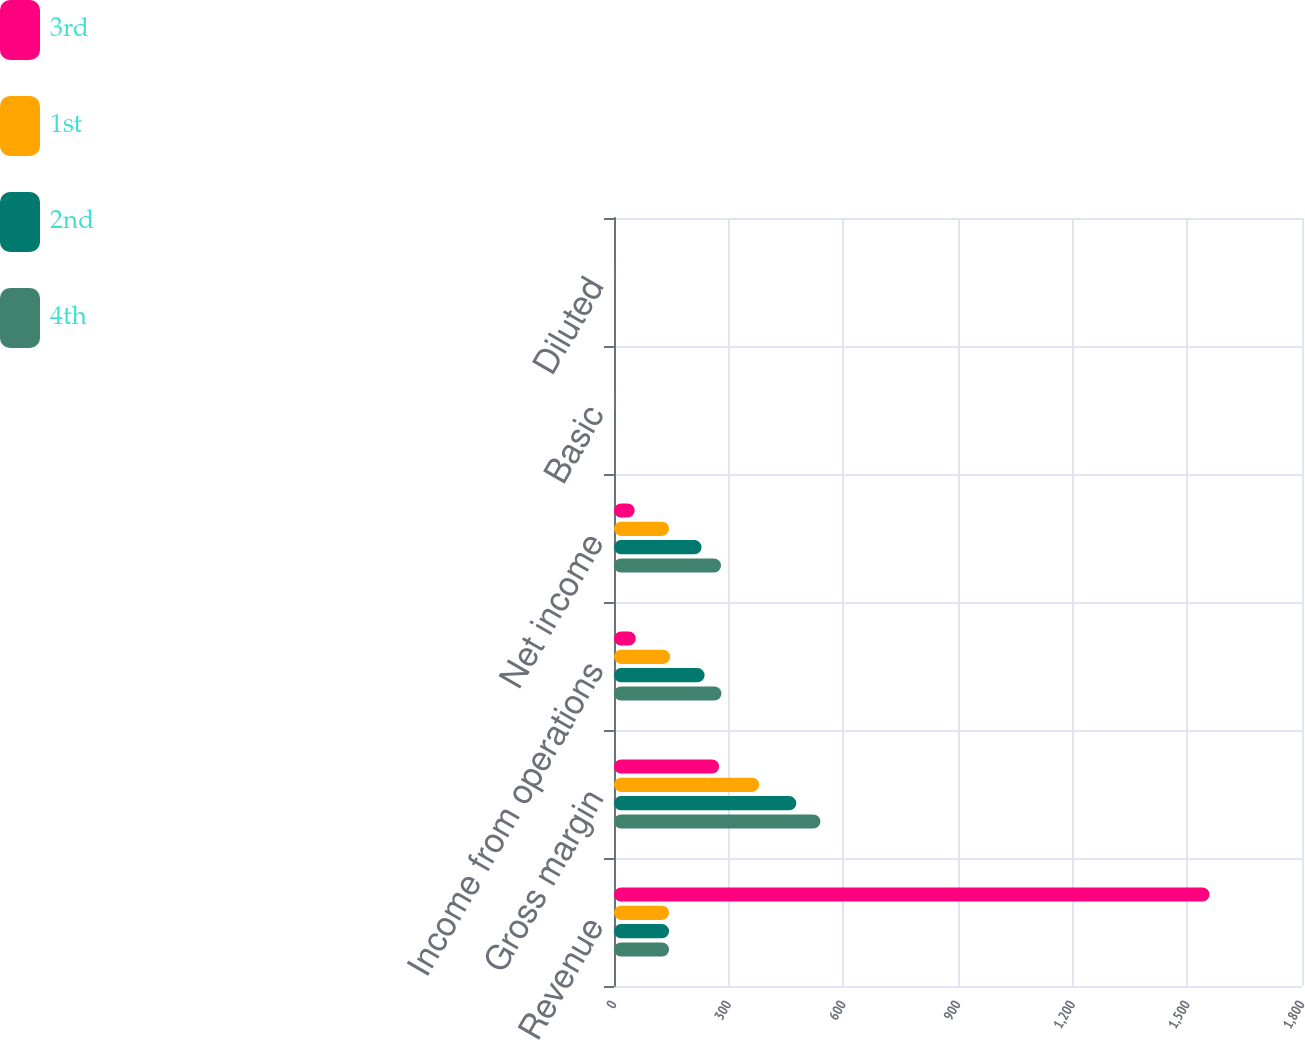Convert chart. <chart><loc_0><loc_0><loc_500><loc_500><stacked_bar_chart><ecel><fcel>Revenue<fcel>Gross margin<fcel>Income from operations<fcel>Net income<fcel>Basic<fcel>Diluted<nl><fcel>3rd<fcel>1558<fcel>275<fcel>57<fcel>54<fcel>0.12<fcel>0.11<nl><fcel>1st<fcel>144<fcel>380<fcel>147<fcel>144<fcel>0.31<fcel>0.29<nl><fcel>2nd<fcel>144<fcel>477<fcel>237<fcel>229<fcel>0.49<fcel>0.45<nl><fcel>4th<fcel>144<fcel>540<fcel>281<fcel>280<fcel>0.59<fcel>0.55<nl></chart> 